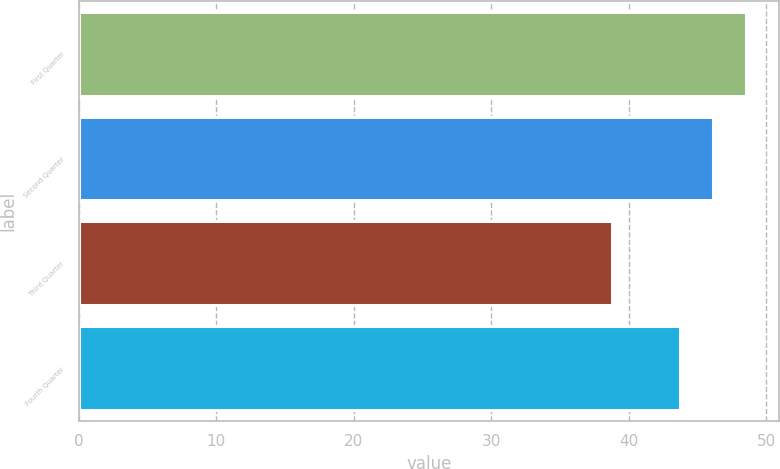Convert chart to OTSL. <chart><loc_0><loc_0><loc_500><loc_500><bar_chart><fcel>First Quarter<fcel>Second Quarter<fcel>Third Quarter<fcel>Fourth Quarter<nl><fcel>48.5<fcel>46.15<fcel>38.75<fcel>43.76<nl></chart> 